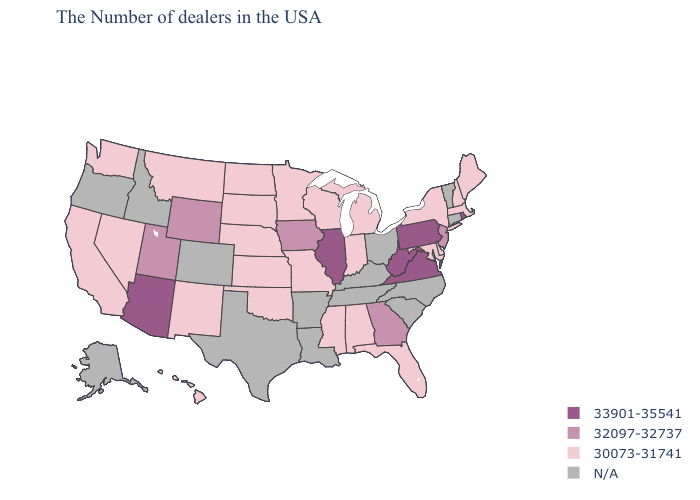Name the states that have a value in the range 32097-32737?
Short answer required. New Jersey, Georgia, Iowa, Wyoming, Utah. What is the lowest value in the USA?
Write a very short answer. 30073-31741. What is the highest value in the West ?
Quick response, please. 33901-35541. What is the lowest value in the West?
Concise answer only. 30073-31741. What is the highest value in states that border Wyoming?
Be succinct. 32097-32737. Among the states that border Missouri , which have the lowest value?
Short answer required. Kansas, Nebraska, Oklahoma. What is the value of Maryland?
Keep it brief. 30073-31741. Name the states that have a value in the range 30073-31741?
Give a very brief answer. Maine, Massachusetts, New Hampshire, New York, Delaware, Maryland, Florida, Michigan, Indiana, Alabama, Wisconsin, Mississippi, Missouri, Minnesota, Kansas, Nebraska, Oklahoma, South Dakota, North Dakota, New Mexico, Montana, Nevada, California, Washington, Hawaii. Name the states that have a value in the range 30073-31741?
Keep it brief. Maine, Massachusetts, New Hampshire, New York, Delaware, Maryland, Florida, Michigan, Indiana, Alabama, Wisconsin, Mississippi, Missouri, Minnesota, Kansas, Nebraska, Oklahoma, South Dakota, North Dakota, New Mexico, Montana, Nevada, California, Washington, Hawaii. Does Pennsylvania have the highest value in the USA?
Concise answer only. Yes. What is the value of North Dakota?
Be succinct. 30073-31741. What is the value of Texas?
Quick response, please. N/A. Which states have the lowest value in the South?
Give a very brief answer. Delaware, Maryland, Florida, Alabama, Mississippi, Oklahoma. Name the states that have a value in the range N/A?
Answer briefly. Vermont, Connecticut, North Carolina, South Carolina, Ohio, Kentucky, Tennessee, Louisiana, Arkansas, Texas, Colorado, Idaho, Oregon, Alaska. Does the map have missing data?
Answer briefly. Yes. 